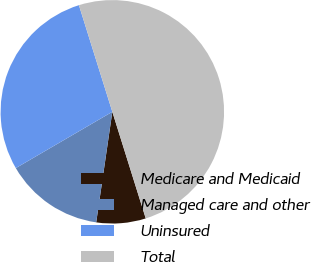Convert chart to OTSL. <chart><loc_0><loc_0><loc_500><loc_500><pie_chart><fcel>Medicare and Medicaid<fcel>Managed care and other<fcel>Uninsured<fcel>Total<nl><fcel>7.14%<fcel>14.29%<fcel>28.57%<fcel>50.0%<nl></chart> 